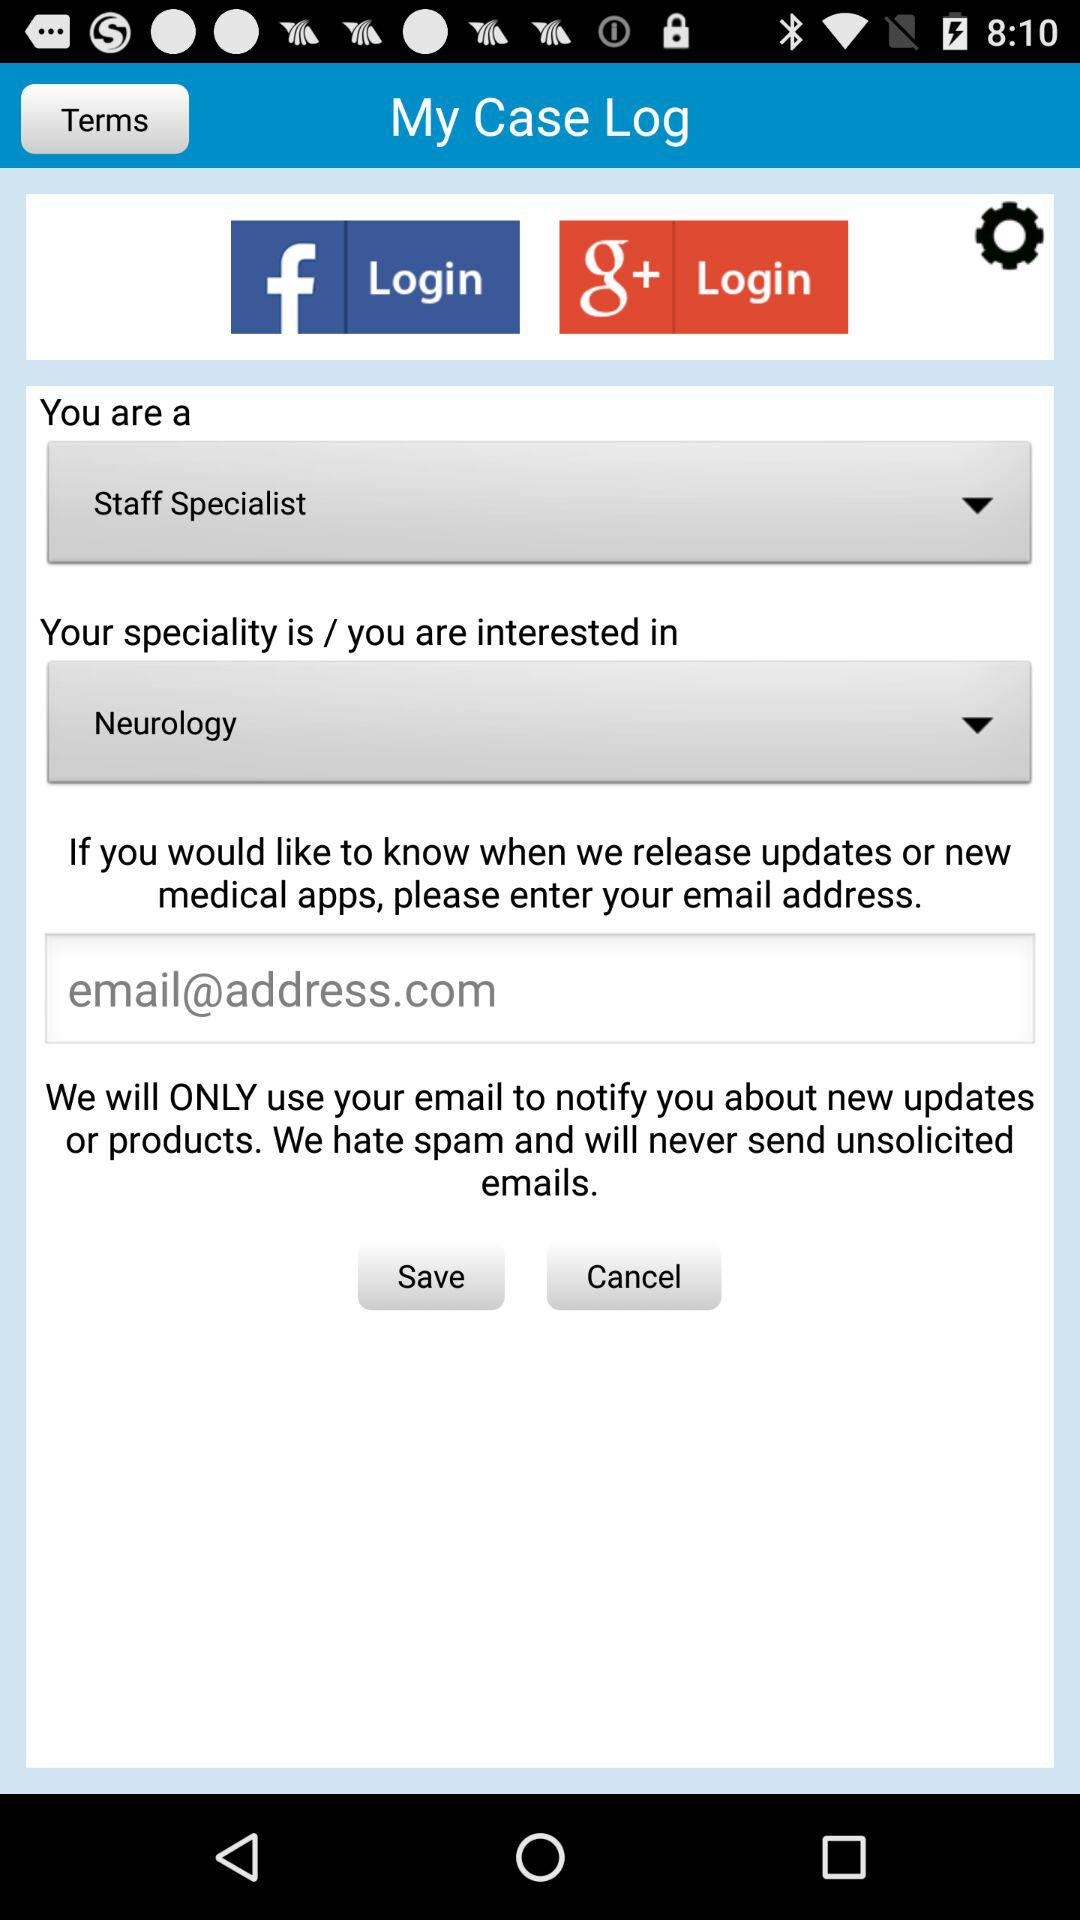Which speciality is selected? The selected speciality is "Neurology". 